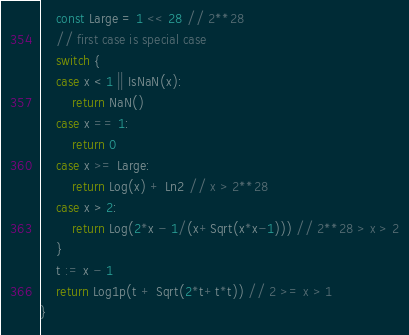<code> <loc_0><loc_0><loc_500><loc_500><_Go_>	const Large = 1 << 28 // 2**28
	// first case is special case
	switch {
	case x < 1 || IsNaN(x):
		return NaN()
	case x == 1:
		return 0
	case x >= Large:
		return Log(x) + Ln2 // x > 2**28
	case x > 2:
		return Log(2*x - 1/(x+Sqrt(x*x-1))) // 2**28 > x > 2
	}
	t := x - 1
	return Log1p(t + Sqrt(2*t+t*t)) // 2 >= x > 1
}
</code> 